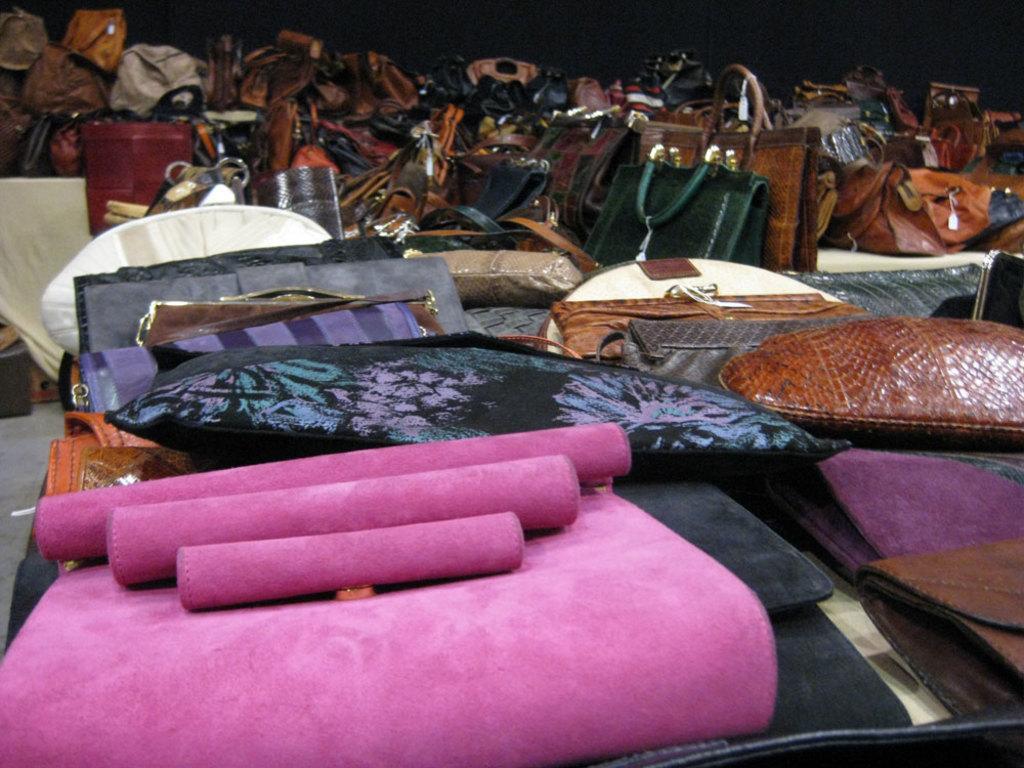How would you summarize this image in a sentence or two? This image consists of many bags and purses kept in a room. At the bottom, there is a floor. 